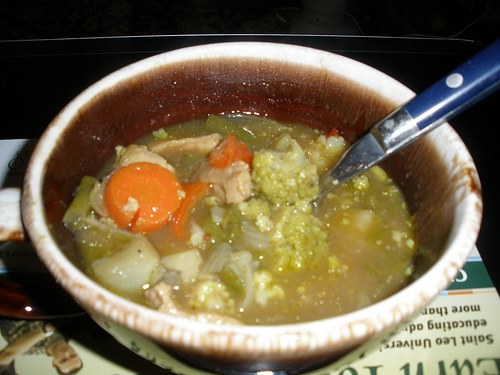Imagine this soup is served at a prestigious culinary competition. How would it be presented and what would the judges say? In a prestigious culinary competition, the soup would be presented in an elegant, handcrafted bowl, possibly with a matching lid to keep it warm until presentation time. The vegetables in the soup would be meticulously cut to uniform sizes, showcasing the chef’s knife skills. Garnishes such as a sprinkle of fresh herbs or a drizzle of high-quality olive oil would add a finishing touch. The judges would appreciate the care taken in the preparation and presentation. They might comment on the rich, aromatic broth, the perfect texture of the vegetables, and the harmonious balance of flavors. The attention to aesthetic detail and the use of fresh, high-quality ingredients would be praised, making it a strong contender for an award. 